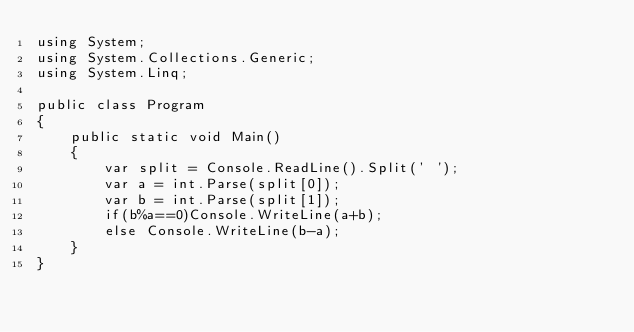<code> <loc_0><loc_0><loc_500><loc_500><_C#_>using System;
using System.Collections.Generic;
using System.Linq;
					
public class Program
{
	public static void Main()
	{
		var split = Console.ReadLine().Split(' ');
		var a = int.Parse(split[0]);
		var b = int.Parse(split[1]);
		if(b%a==0)Console.WriteLine(a+b); 
		else Console.WriteLine(b-a);
	}
}</code> 